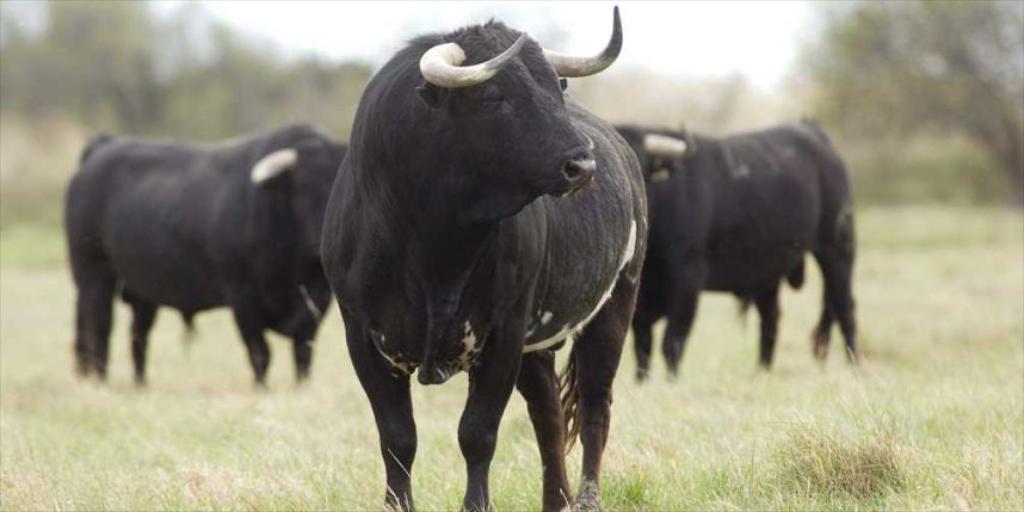Can you describe this image briefly? In this picture I can observe bulls. These bills are in black color. I can observe grass on the ground. The background is blurred. 